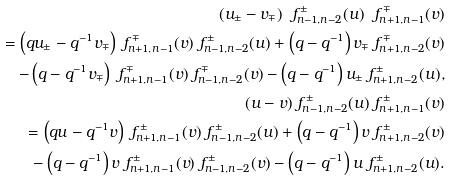Convert formula to latex. <formula><loc_0><loc_0><loc_500><loc_500>( u _ { \pm } - v _ { \mp } ) \ f _ { n - 1 , n - 2 } ^ { \pm } ( u ) \ f _ { n + 1 , n - 1 } ^ { \mp } ( v ) \\ = \left ( q u _ { \pm } - q ^ { - 1 } v _ { \mp } \right ) \ f _ { n + 1 , n - 1 } ^ { \mp } ( v ) \ f _ { n - 1 , n - 2 } ^ { \pm } ( u ) + \left ( q - q ^ { - 1 } \right ) v _ { \mp } \ f _ { n + 1 , n - 2 } ^ { \mp } ( v ) \\ \quad - \left ( q - q ^ { - 1 } v _ { \mp } \right ) \ f _ { n + 1 , n - 1 } ^ { \mp } ( v ) \ f _ { n - 1 , n - 2 } ^ { \mp } ( v ) - \left ( q - q ^ { - 1 } \right ) u _ { \pm } \ f _ { n + 1 , n - 2 } ^ { \pm } ( u ) , \\ ( u - v ) \ f _ { n - 1 , n - 2 } ^ { \pm } ( u ) \ f _ { n + 1 , n - 1 } ^ { \pm } ( v ) \\ = \left ( q u - q ^ { - 1 } v \right ) \ f _ { n + 1 , n - 1 } ^ { \pm } ( v ) \ f _ { n - 1 , n - 2 } ^ { \pm } ( u ) + \left ( q - q ^ { - 1 } \right ) v \ f _ { n + 1 , n - 2 } ^ { \pm } ( v ) \\ \quad - \left ( q - q ^ { - 1 } \right ) v \ f _ { n + 1 , n - 1 } ^ { \pm } ( v ) \ f _ { n - 1 , n - 2 } ^ { \pm } ( v ) - \left ( q - q ^ { - 1 } \right ) u \ f _ { n + 1 , n - 2 } ^ { \pm } ( u ) .</formula> 